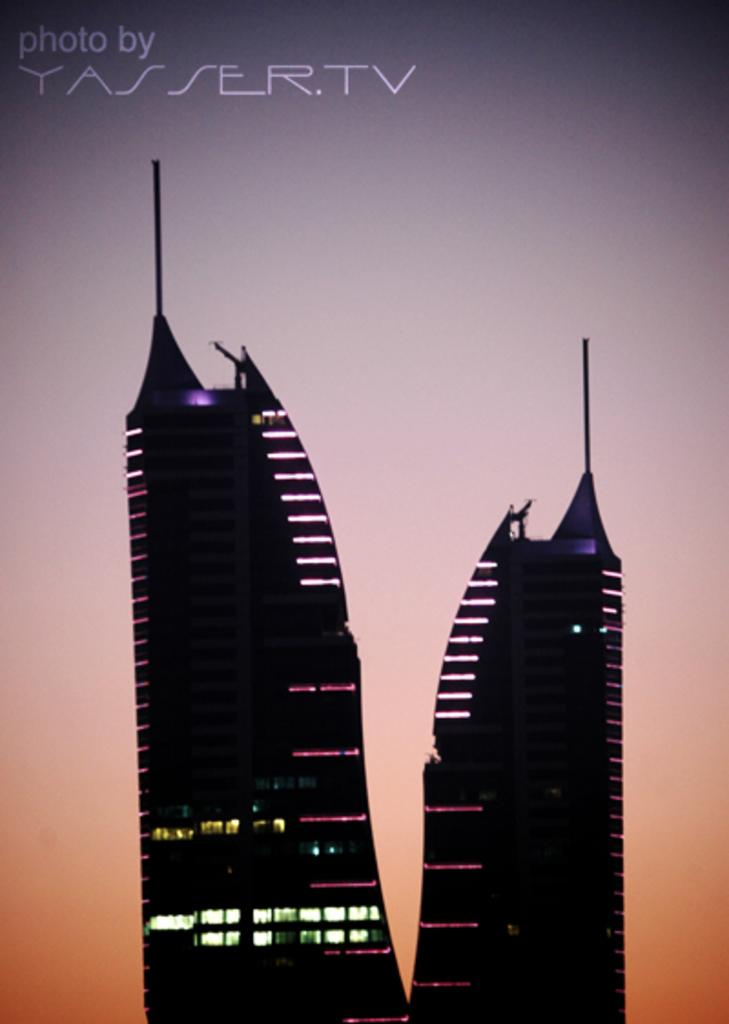What type of structure is the main subject of the image? There is a tower building in the image. What is on top of the tower building? The tower building has a light on top and poles. What type of image is this? The image is a photograph. What is the label or title of the photograph? The photograph is labeled as "TASSER TV." What type of riddle is the queen solving in the image? There is no queen or riddle present in the image; it features a tower building with a light and poles on top. 